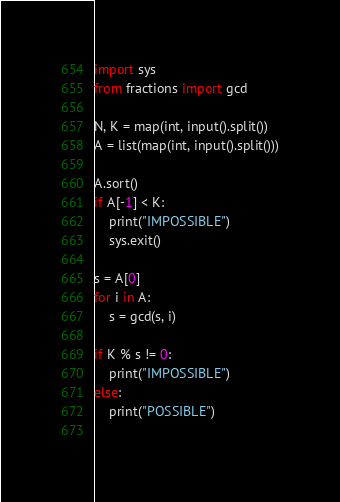<code> <loc_0><loc_0><loc_500><loc_500><_Python_>import sys
from fractions import gcd

N, K = map(int, input().split())
A = list(map(int, input().split()))

A.sort()
if A[-1] < K:
    print("IMPOSSIBLE")
    sys.exit()
    
s = A[0]
for i in A:
    s = gcd(s, i)

if K % s != 0:
    print("IMPOSSIBLE")
else:
    print("POSSIBLE")
    </code> 